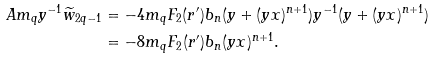<formula> <loc_0><loc_0><loc_500><loc_500>A m _ { q } y ^ { - 1 } \widetilde { w } _ { 2 q - 1 } & = - 4 m _ { q } F _ { 2 } ( r ^ { \prime } ) b _ { n } ( y + ( y x ) ^ { n + 1 } ) y ^ { - 1 } ( y + ( y x ) ^ { n + 1 } ) \\ & = - 8 m _ { q } F _ { 2 } ( r ^ { \prime } ) b _ { n } ( y x ) ^ { n + 1 } .</formula> 